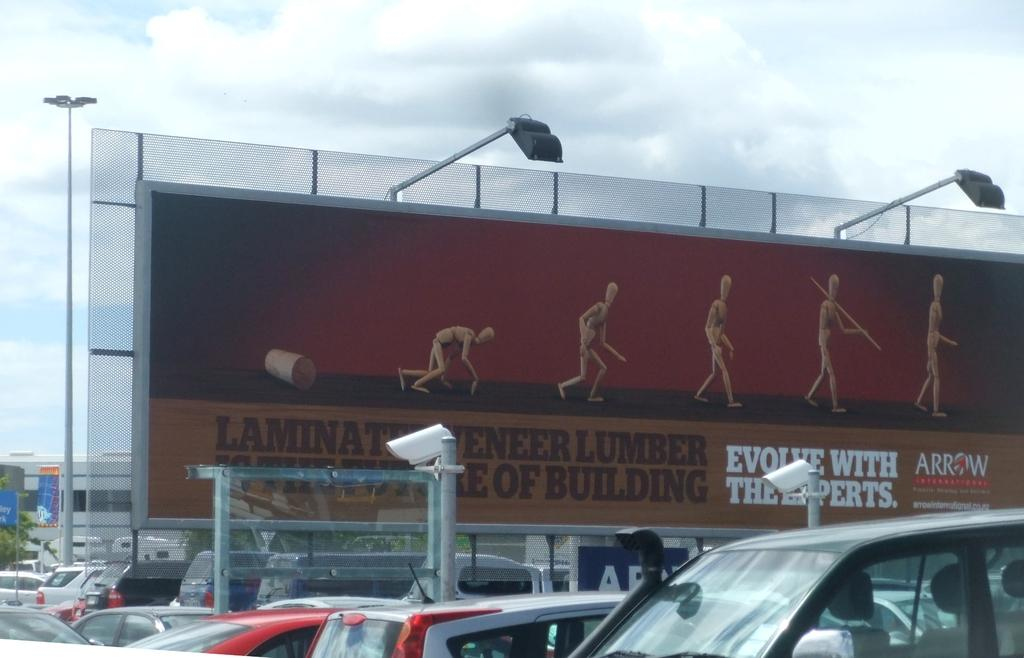<image>
Render a clear and concise summary of the photo. The advertisement says Laminate Veneer Lumbar is the future of building. 